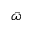<formula> <loc_0><loc_0><loc_500><loc_500>\bar { \omega }</formula> 